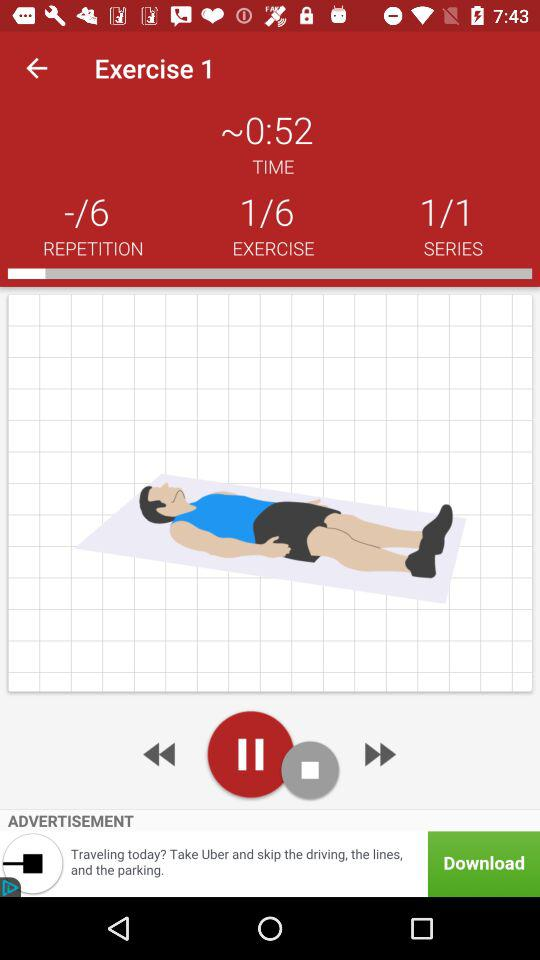What is the total number of series? The total number of series is 1. 